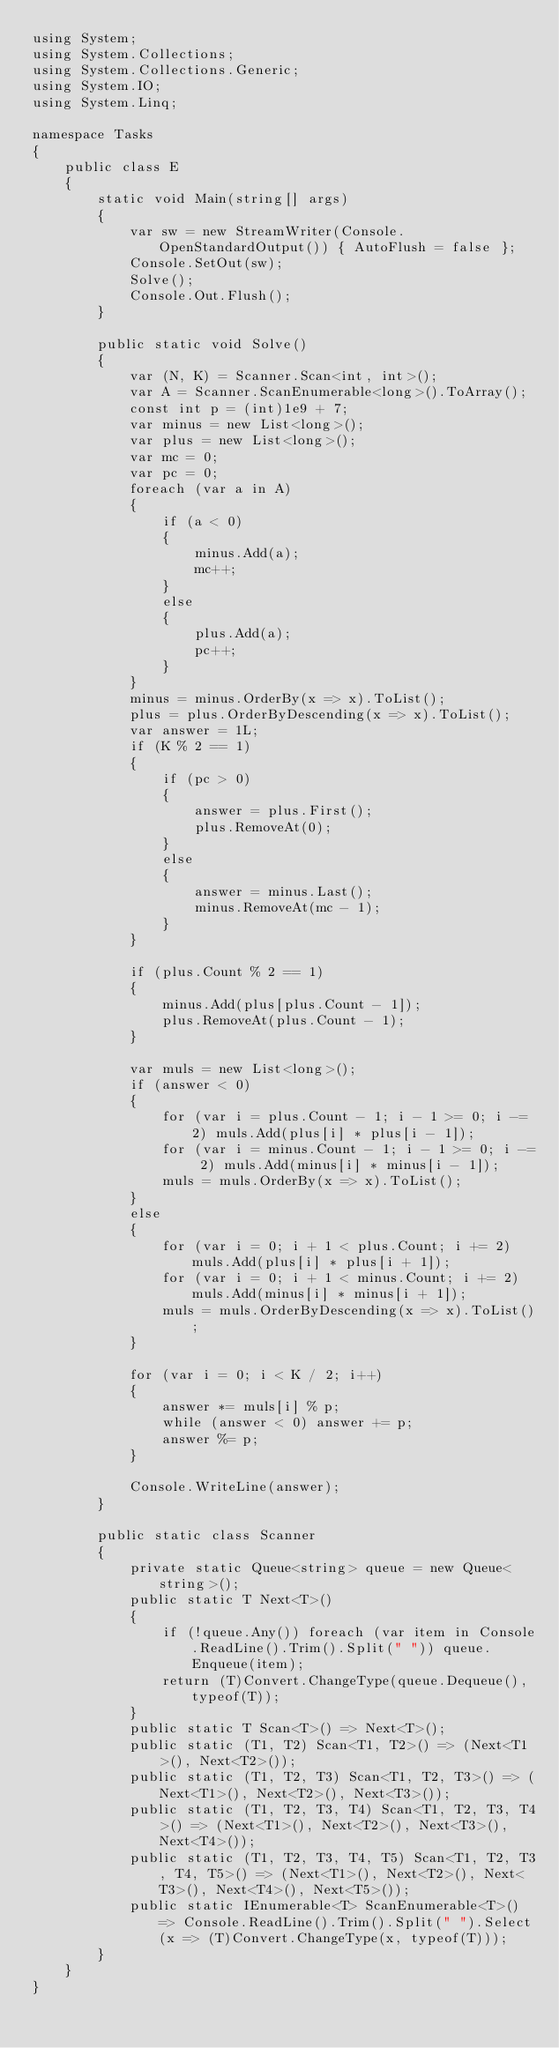Convert code to text. <code><loc_0><loc_0><loc_500><loc_500><_C#_>using System;
using System.Collections;
using System.Collections.Generic;
using System.IO;
using System.Linq;

namespace Tasks
{
    public class E
    {
        static void Main(string[] args)
        {
            var sw = new StreamWriter(Console.OpenStandardOutput()) { AutoFlush = false };
            Console.SetOut(sw);
            Solve();
            Console.Out.Flush();
        }

        public static void Solve()
        {
            var (N, K) = Scanner.Scan<int, int>();
            var A = Scanner.ScanEnumerable<long>().ToArray();
            const int p = (int)1e9 + 7;
            var minus = new List<long>();
            var plus = new List<long>();
            var mc = 0;
            var pc = 0;
            foreach (var a in A)
            {
                if (a < 0)
                {
                    minus.Add(a);
                    mc++;
                }
                else
                {
                    plus.Add(a);
                    pc++;
                }
            }
            minus = minus.OrderBy(x => x).ToList();
            plus = plus.OrderByDescending(x => x).ToList();
            var answer = 1L;
            if (K % 2 == 1)
            {
                if (pc > 0)
                {
                    answer = plus.First();
                    plus.RemoveAt(0);
                }
                else
                {
                    answer = minus.Last();
                    minus.RemoveAt(mc - 1);
                }
            }

            if (plus.Count % 2 == 1)
            {
                minus.Add(plus[plus.Count - 1]);
                plus.RemoveAt(plus.Count - 1);
            }

            var muls = new List<long>();
            if (answer < 0)
            {
                for (var i = plus.Count - 1; i - 1 >= 0; i -= 2) muls.Add(plus[i] * plus[i - 1]);
                for (var i = minus.Count - 1; i - 1 >= 0; i -= 2) muls.Add(minus[i] * minus[i - 1]);
                muls = muls.OrderBy(x => x).ToList();
            }
            else
            {
                for (var i = 0; i + 1 < plus.Count; i += 2) muls.Add(plus[i] * plus[i + 1]);
                for (var i = 0; i + 1 < minus.Count; i += 2) muls.Add(minus[i] * minus[i + 1]);
                muls = muls.OrderByDescending(x => x).ToList();
            }

            for (var i = 0; i < K / 2; i++)
            {
                answer *= muls[i] % p;
                while (answer < 0) answer += p;
                answer %= p;
            }

            Console.WriteLine(answer);
        }

        public static class Scanner
        {
            private static Queue<string> queue = new Queue<string>();
            public static T Next<T>()
            {
                if (!queue.Any()) foreach (var item in Console.ReadLine().Trim().Split(" ")) queue.Enqueue(item);
                return (T)Convert.ChangeType(queue.Dequeue(), typeof(T));
            }
            public static T Scan<T>() => Next<T>();
            public static (T1, T2) Scan<T1, T2>() => (Next<T1>(), Next<T2>());
            public static (T1, T2, T3) Scan<T1, T2, T3>() => (Next<T1>(), Next<T2>(), Next<T3>());
            public static (T1, T2, T3, T4) Scan<T1, T2, T3, T4>() => (Next<T1>(), Next<T2>(), Next<T3>(), Next<T4>());
            public static (T1, T2, T3, T4, T5) Scan<T1, T2, T3, T4, T5>() => (Next<T1>(), Next<T2>(), Next<T3>(), Next<T4>(), Next<T5>());
            public static IEnumerable<T> ScanEnumerable<T>() => Console.ReadLine().Trim().Split(" ").Select(x => (T)Convert.ChangeType(x, typeof(T)));
        }
    }
}
</code> 